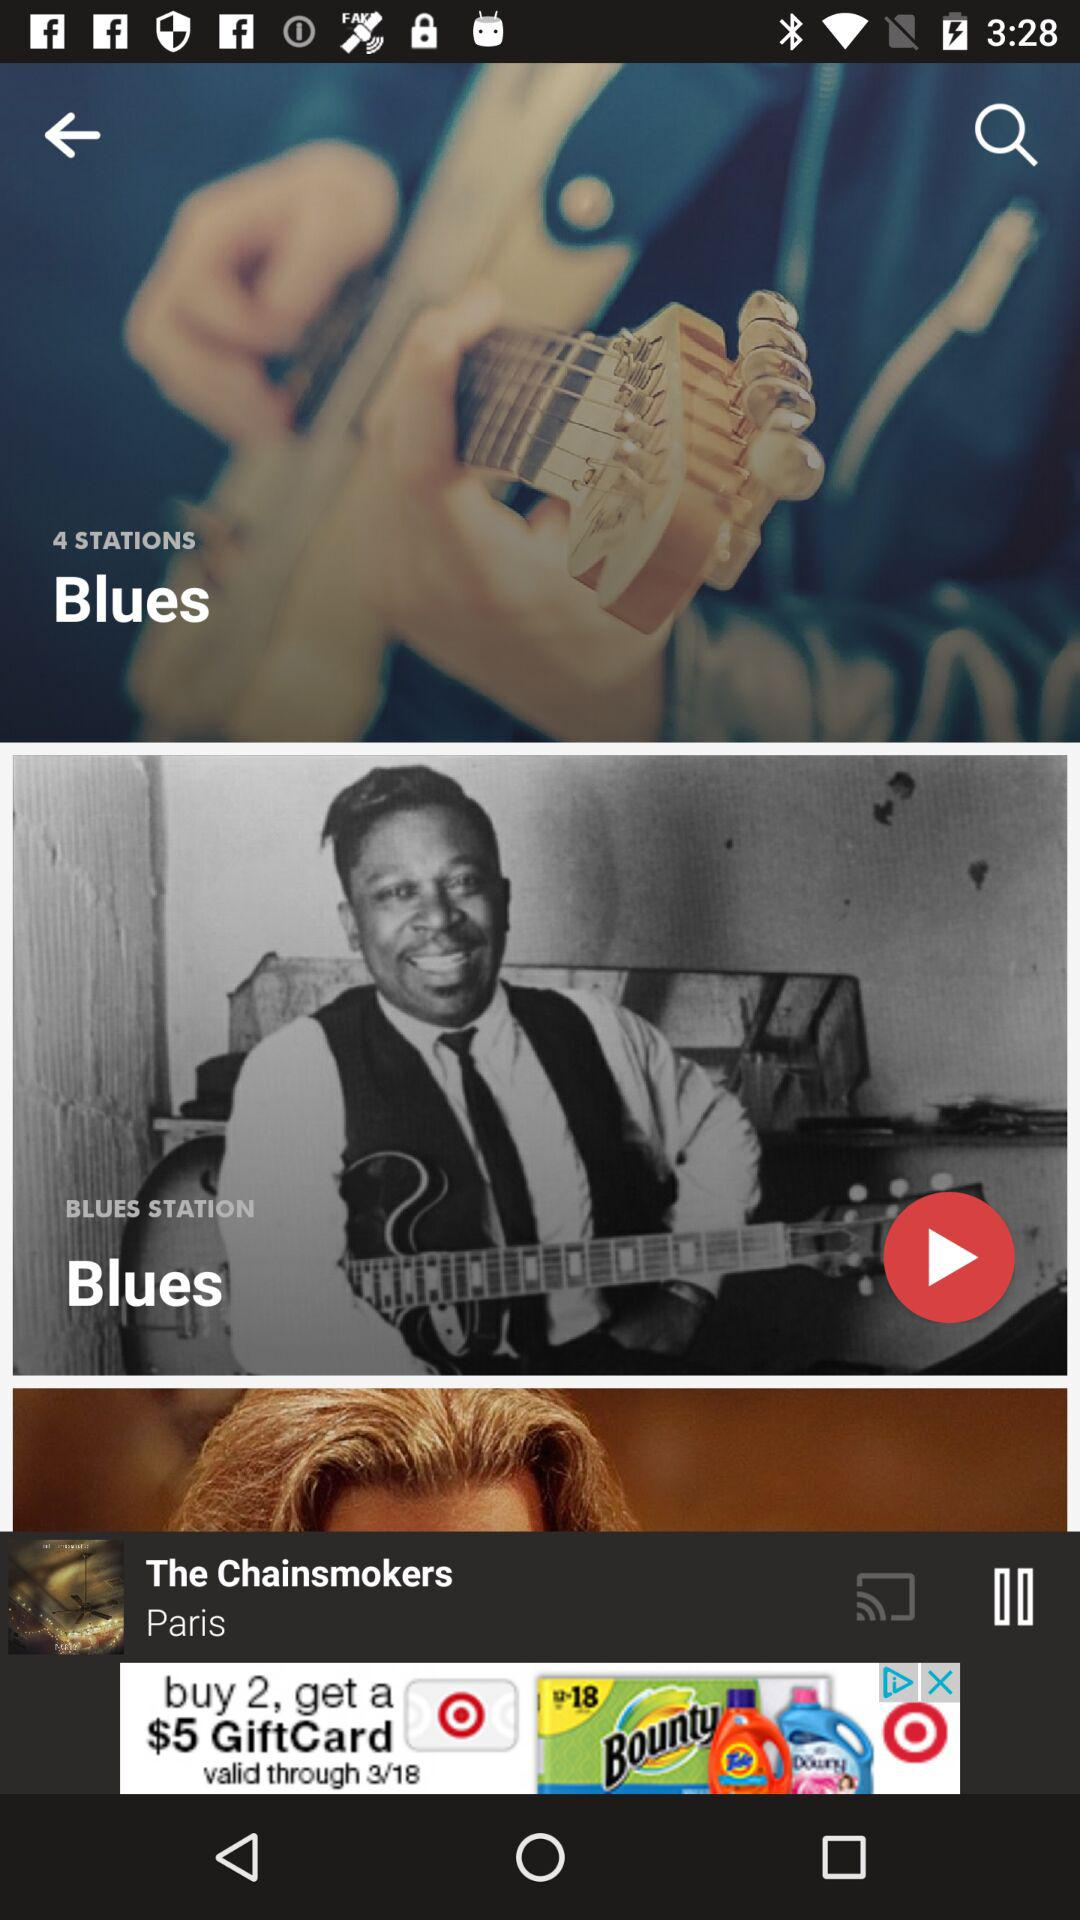How many stations are there?
Answer the question using a single word or phrase. 4 